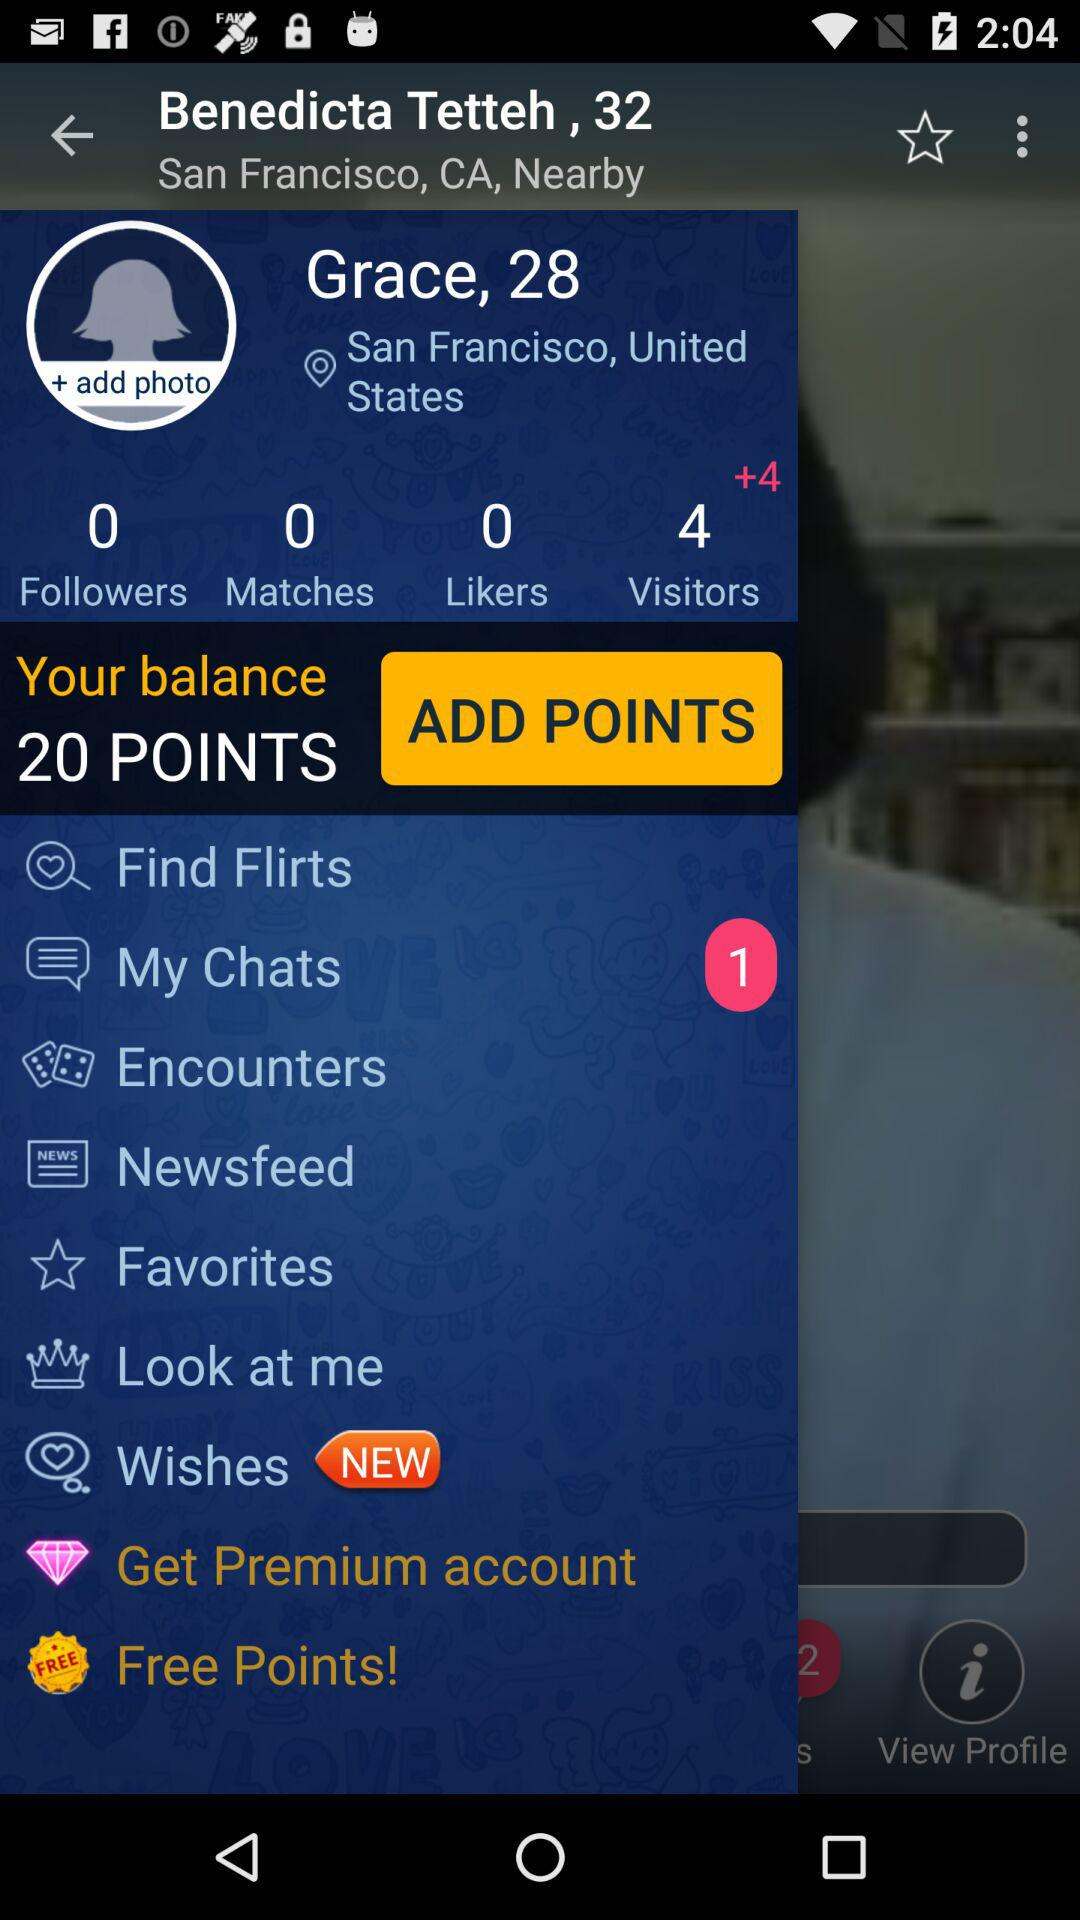What is the age of the user? The age of the user is 28 years. 